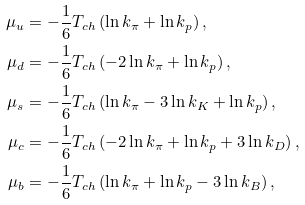Convert formula to latex. <formula><loc_0><loc_0><loc_500><loc_500>\mu _ { u } & = - \frac { 1 } { 6 } T _ { c h } \left ( \ln k _ { \pi } + \ln k _ { p } \right ) , \\ \mu _ { d } & = - \frac { 1 } { 6 } T _ { c h } \left ( - 2 \ln k _ { \pi } + \ln k _ { p } \right ) , \\ \mu _ { s } & = - \frac { 1 } { 6 } T _ { c h } \left ( \ln k _ { \pi } - 3 \ln k _ { K } + \ln k _ { p } \right ) , \\ \mu _ { c } & = - \frac { 1 } { 6 } T _ { c h } \left ( - 2 \ln k _ { \pi } + \ln k _ { p } + 3 \ln k _ { D } \right ) , \\ \mu _ { b } & = - \frac { 1 } { 6 } T _ { c h } \left ( \ln k _ { \pi } + \ln k _ { p } - 3 \ln k _ { B } \right ) ,</formula> 